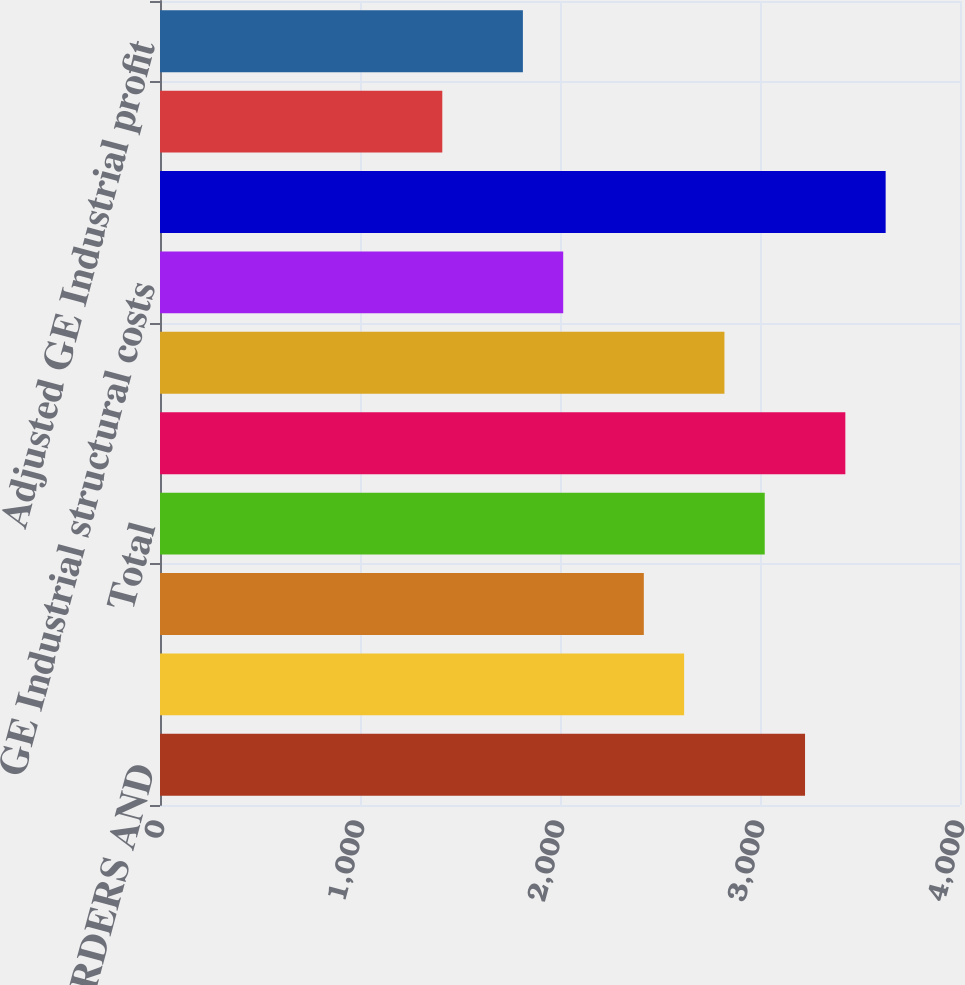Convert chart to OTSL. <chart><loc_0><loc_0><loc_500><loc_500><bar_chart><fcel>GE INDUSTRIAL ORDERS AND<fcel>Equipment<fcel>Services(a)<fcel>Total<fcel>GE INDUSTRIAL COSTS (In<fcel>GE total costs and expenses<fcel>GE Industrial structural costs<fcel>GE INDUSTRIAL PROFIT MARGIN<fcel>GE Industrial profit margin<fcel>Adjusted GE Industrial profit<nl><fcel>3225.18<fcel>2620.61<fcel>2419.08<fcel>3023.66<fcel>3426.7<fcel>2822.14<fcel>2016.03<fcel>3628.22<fcel>1411.44<fcel>1814.5<nl></chart> 